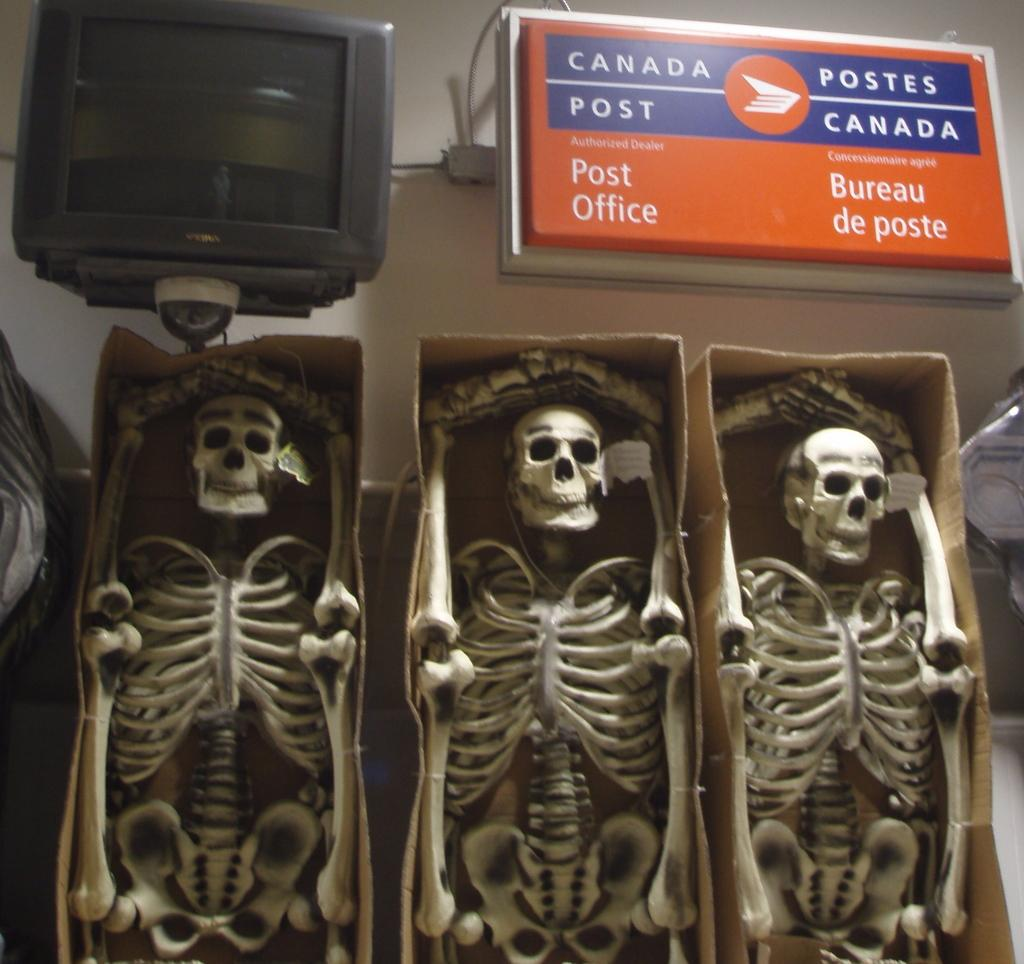What objects are inside the boxes in the image? There are skeletons in boxes in the image. What electronic device is present in the image? There is a television in the image. What can be seen written on a board in the image? There is text written on a board in the image. Where is the girl sitting on the shelf in the image? There is no girl present in the image, and no shelf is mentioned in the provided facts. 